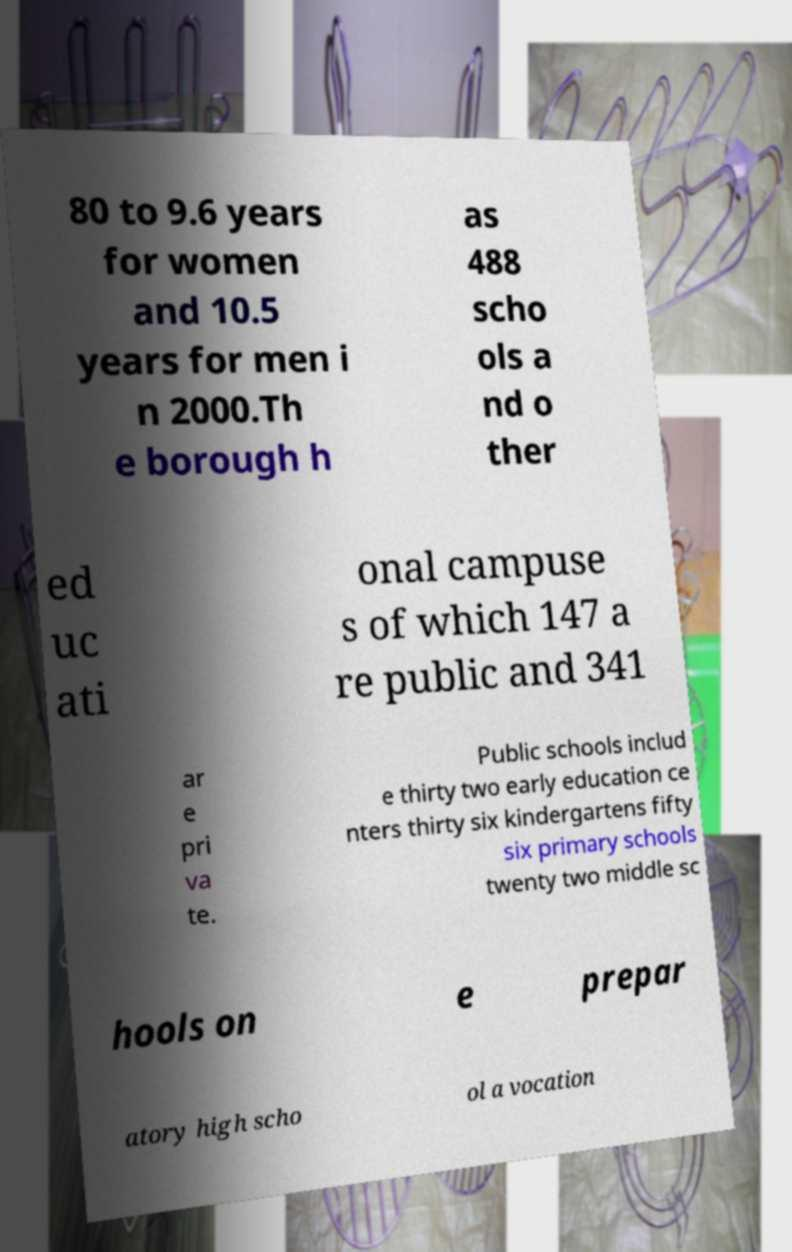Could you extract and type out the text from this image? 80 to 9.6 years for women and 10.5 years for men i n 2000.Th e borough h as 488 scho ols a nd o ther ed uc ati onal campuse s of which 147 a re public and 341 ar e pri va te. Public schools includ e thirty two early education ce nters thirty six kindergartens fifty six primary schools twenty two middle sc hools on e prepar atory high scho ol a vocation 